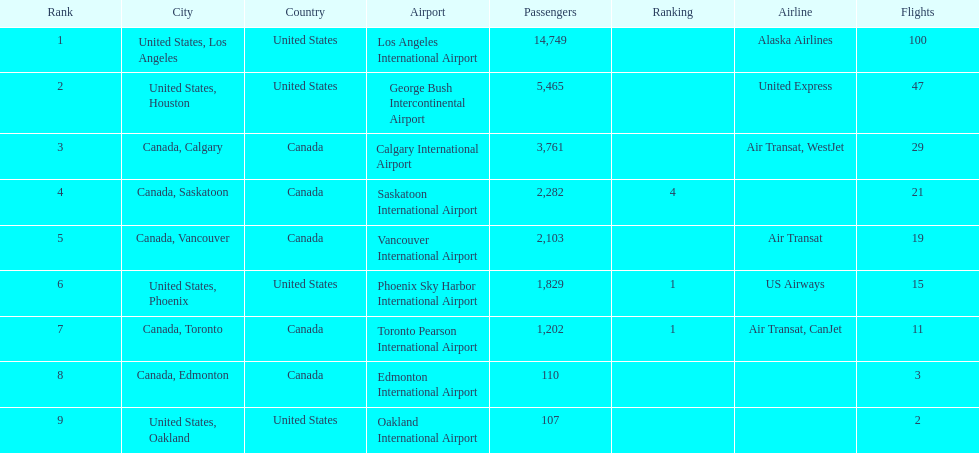Los angeles and what other city had about 19,000 passenger combined Canada, Calgary. 